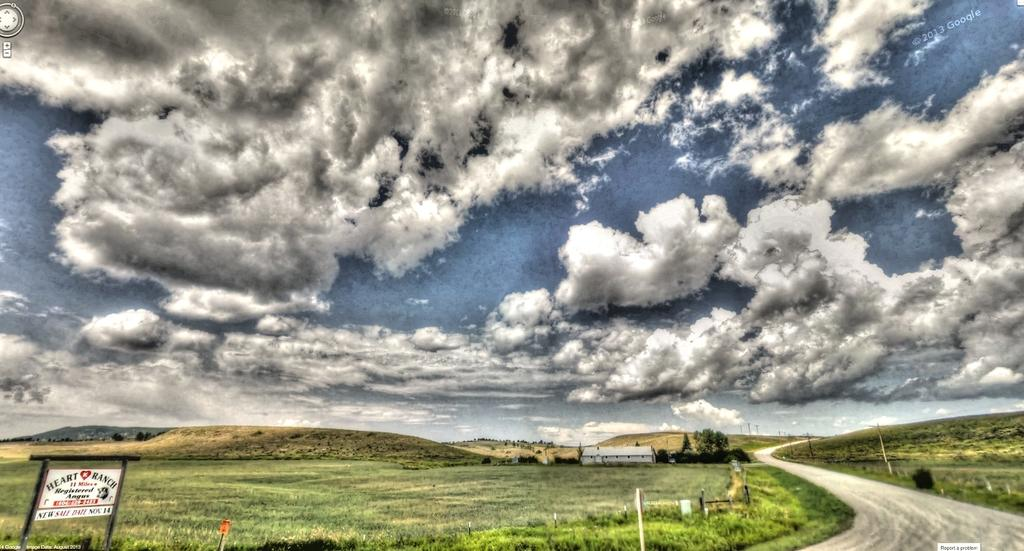What type of structures can be seen in the image? There are poles and a house visible in the image. What type of natural elements are present in the image? There are trees, grass, mountains, and clouds in the image. What type of man-made structures can be seen in the image? There is a road and a board with text in the image. What is visible in the sky in the image? The sky is visible in the image, and there are clouds present. Can you tell me how many times the word "regret" appears on the board with text in the image? There is no mention of the word "regret" on the board with text in the image. What type of facial expression can be seen on the zipper in the image? There is no zipper present in the image, and therefore no facial expression can be observed. 